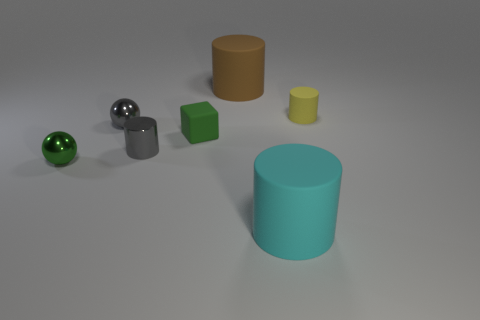What number of objects are either small objects that are to the left of the tiny gray metal sphere or rubber objects that are to the left of the yellow matte cylinder?
Your answer should be very brief. 4. What is the shape of the green object that is the same material as the cyan cylinder?
Your answer should be compact. Cube. Is there anything else of the same color as the tiny matte cylinder?
Offer a very short reply. No. What material is the other tiny object that is the same shape as the tiny green shiny thing?
Provide a short and direct response. Metal. What number of other objects are there of the same size as the gray metallic cylinder?
Offer a terse response. 4. What is the big brown thing made of?
Provide a succinct answer. Rubber. Is the number of small green cubes to the right of the cyan cylinder greater than the number of small yellow cylinders?
Your answer should be compact. No. Is there a small cyan rubber sphere?
Ensure brevity in your answer.  No. What number of other objects are there of the same shape as the tiny yellow matte thing?
Keep it short and to the point. 3. There is a small matte object that is left of the tiny yellow cylinder; is its color the same as the large thing that is in front of the tiny green matte thing?
Offer a terse response. No. 